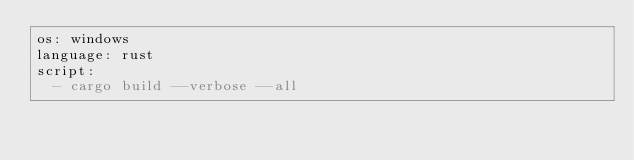<code> <loc_0><loc_0><loc_500><loc_500><_YAML_>os: windows
language: rust
script:
  - cargo build --verbose --all
</code> 